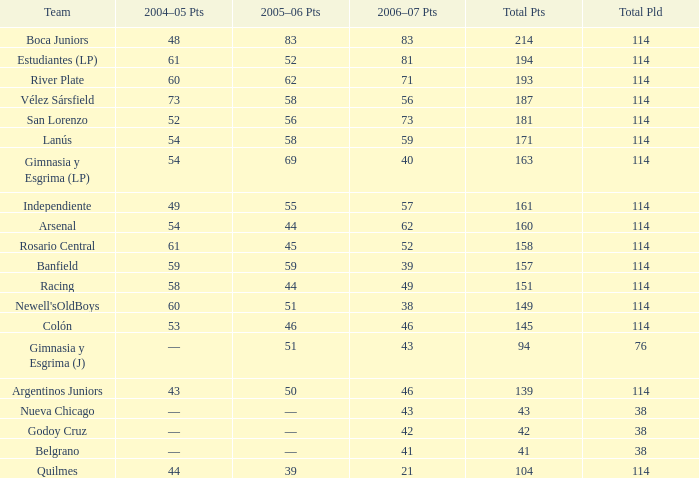What is the combined amount of points for a total pld under 38? 0.0. 